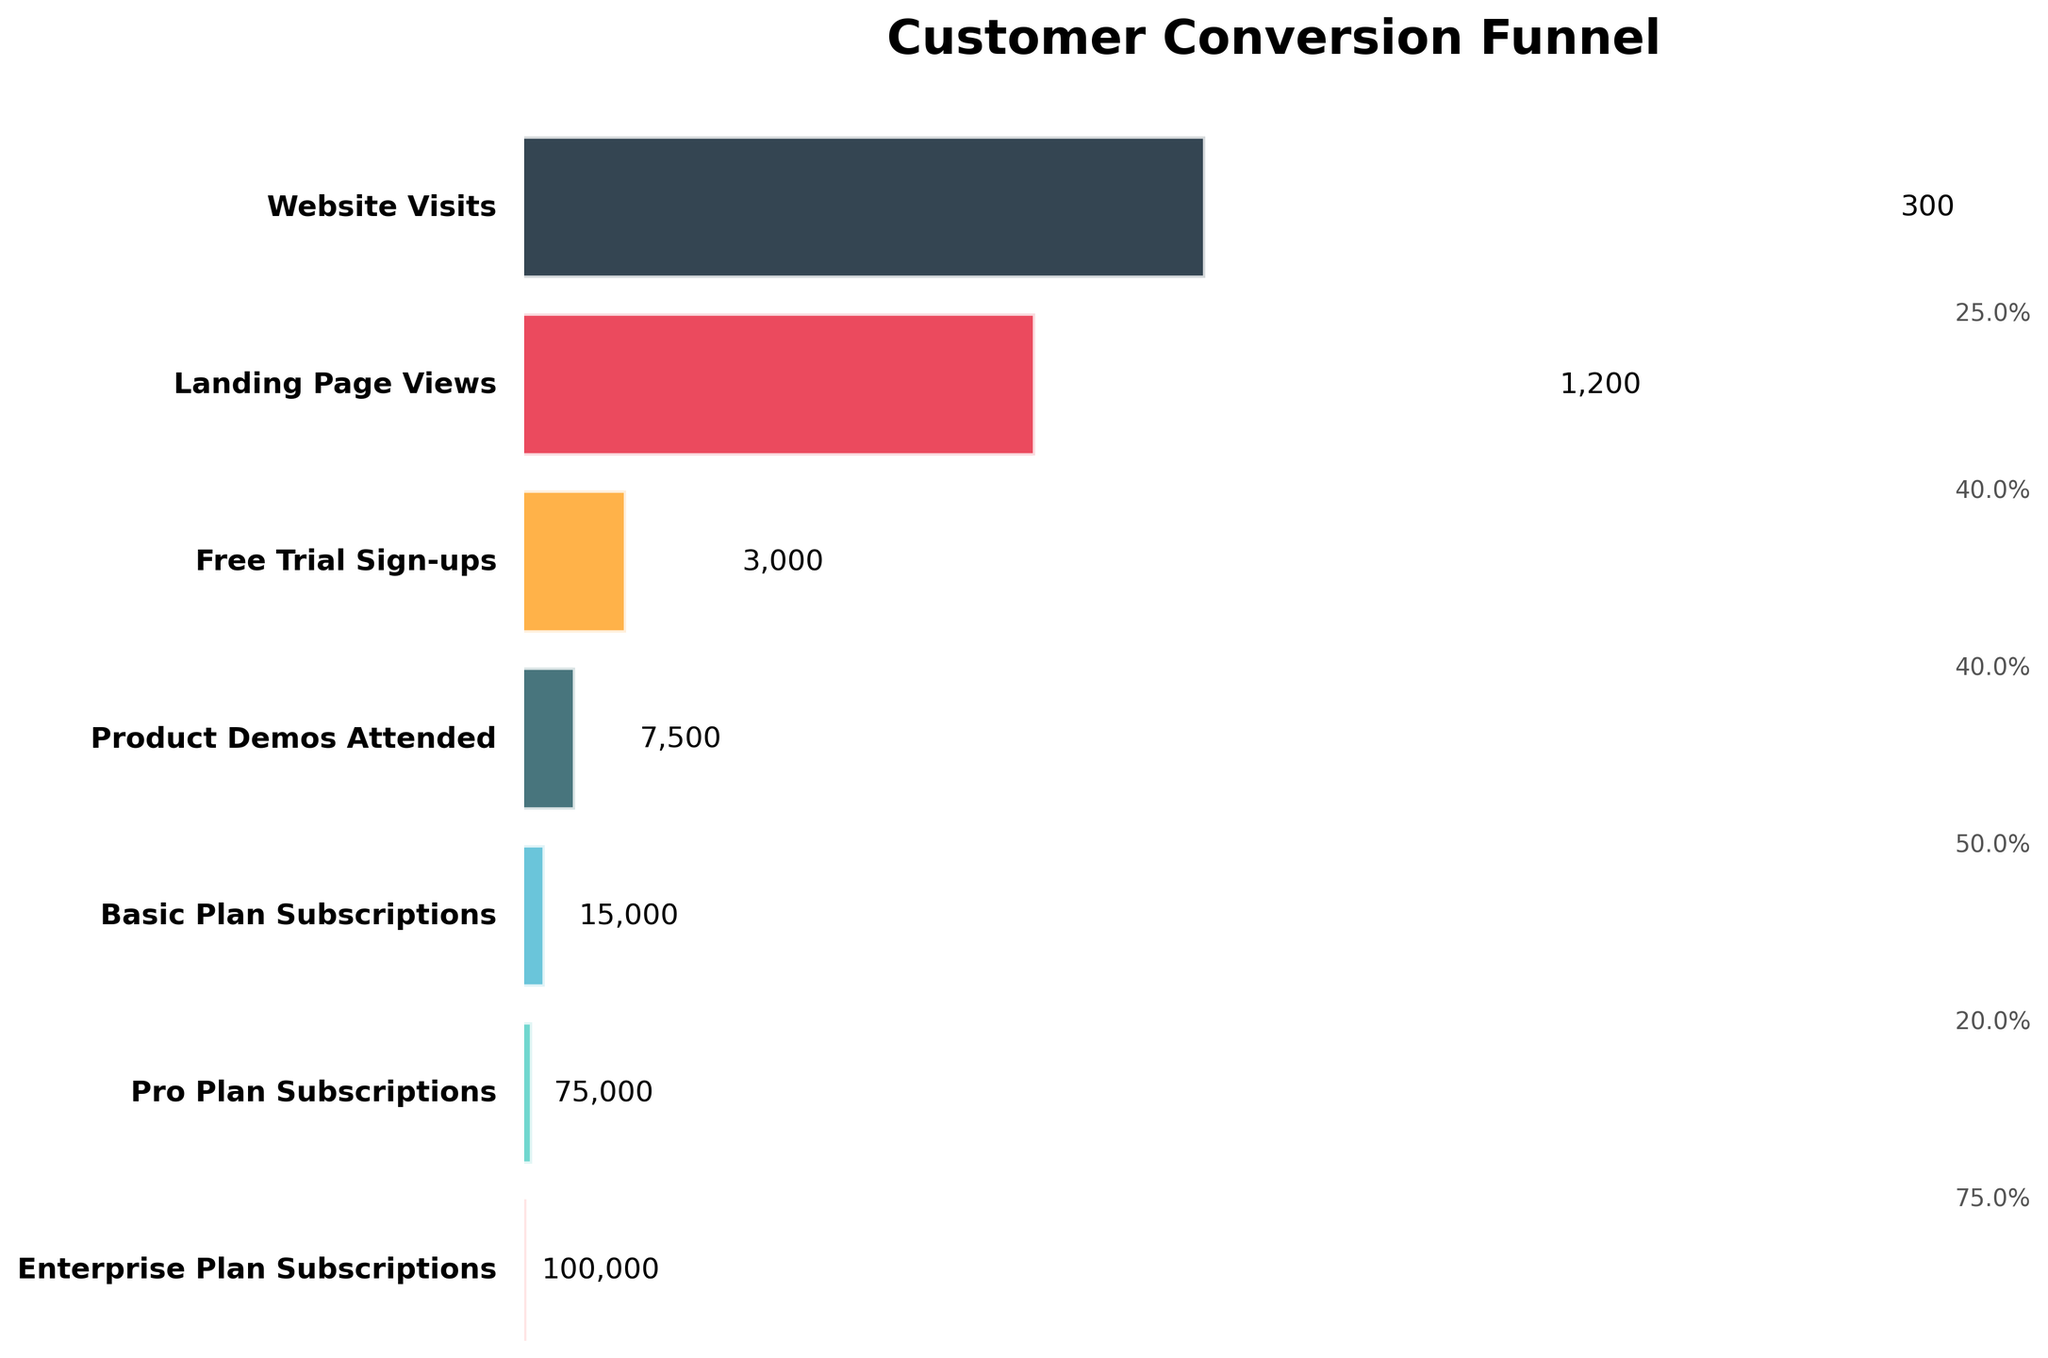What's the title of the figure? The title of the figure is displayed at the top, above the funnel chart.
Answer: Customer Conversion Funnel How many stages are shown in the funnel chart? Count all the unique stages displayed in the funnel chart, starting from the top to the bottom.
Answer: 7 How many users signed up for the Free Trial? Look at the label corresponding to the Free Trial Sign-ups stage in the funnel chart and read the number of users directly from it.
Answer: 15,000 Which stage has the highest number of users? Identify the stage with the widest bar at the top of the funnel chart, representing the stage with the highest number of users.
Answer: Website Visits What percentage of users who signed up for the Free Trial attended a Product Demo? Calculate the percentage by dividing the number of users who attended Product Demos by the number who signed up for the Free Trial and then multiply by 100. (7,500 / 15,000) * 100 = 50%
Answer: 50% What is the difference in user numbers between the Basic and Pro Plan Subscriptions stages? Subtract the number of users of the Pro Plan Subscriptions from the number of users of the Basic Plan Subscriptions. 3,000 - 1,200 = 1,800.
Answer: 1,800 How many users were lost between the Landing Page Views and the Free Trial Sign-ups stages? Subtract the number of users who signed up for the Free Trial from those who viewed the Landing Page. 75,000 - 15,000 = 60,000.
Answer: 60,000 Which subscription plan has the fewest users? Identify the stage with the narrowest bar at the bottom of the funnel chart, representing the minimum number of users.
Answer: Enterprise Plan Subscriptions By what percentage did user numbers decrease from the Landings Page Views to Free Trial Sign-ups stage? Calculate the decrease by subtracting the number of Free Trial Sign-ups from Landing Page Views, divide by Landing Page Views, and multiply by 100. ((75,000 - 15,000) / 75,000) * 100 = 80%.
Answer: 80% 